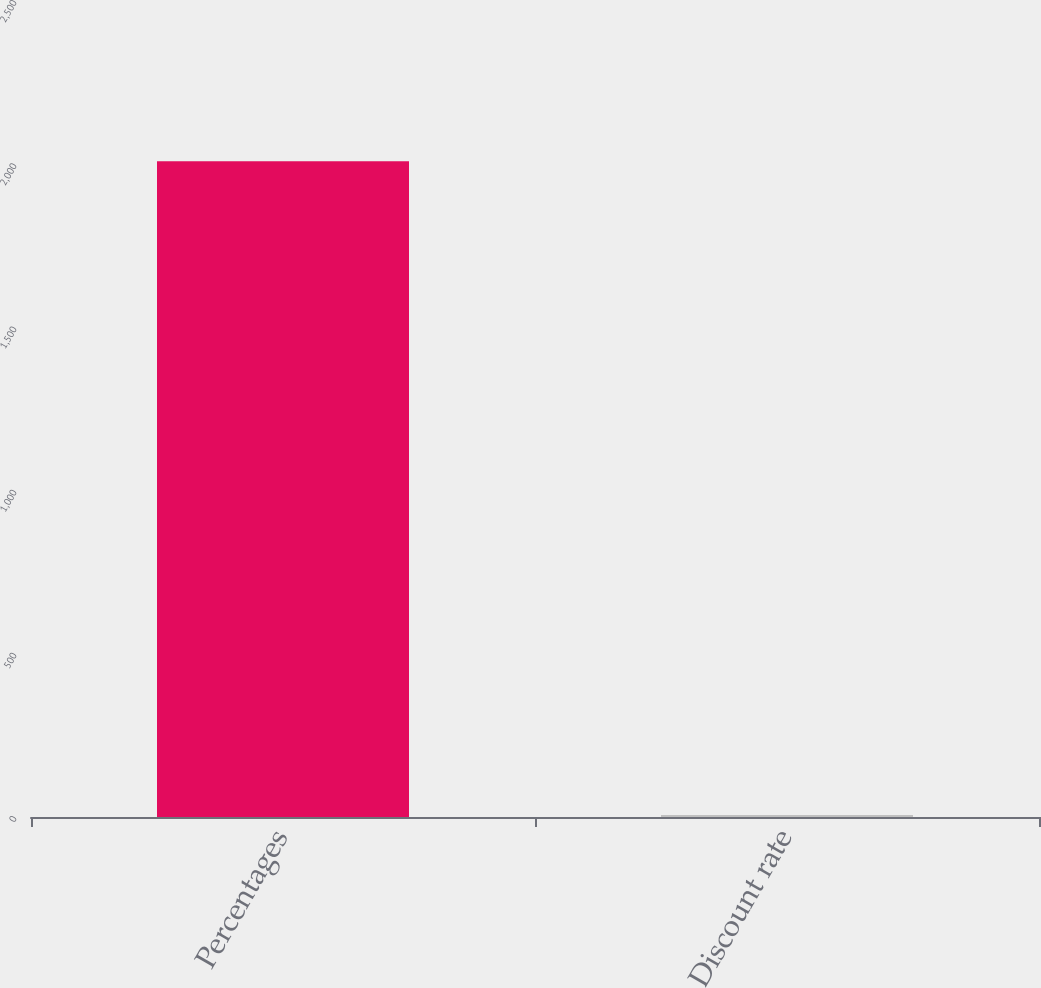<chart> <loc_0><loc_0><loc_500><loc_500><bar_chart><fcel>Percentages<fcel>Discount rate<nl><fcel>2009<fcel>6.25<nl></chart> 